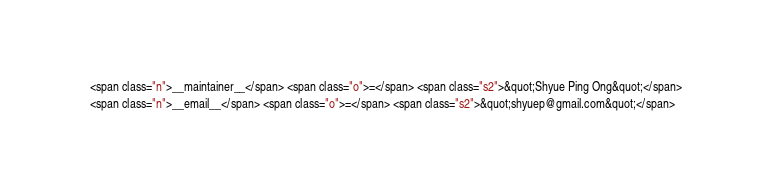Convert code to text. <code><loc_0><loc_0><loc_500><loc_500><_HTML_><span class="n">__maintainer__</span> <span class="o">=</span> <span class="s2">&quot;Shyue Ping Ong&quot;</span>
<span class="n">__email__</span> <span class="o">=</span> <span class="s2">&quot;shyuep@gmail.com&quot;</span></code> 